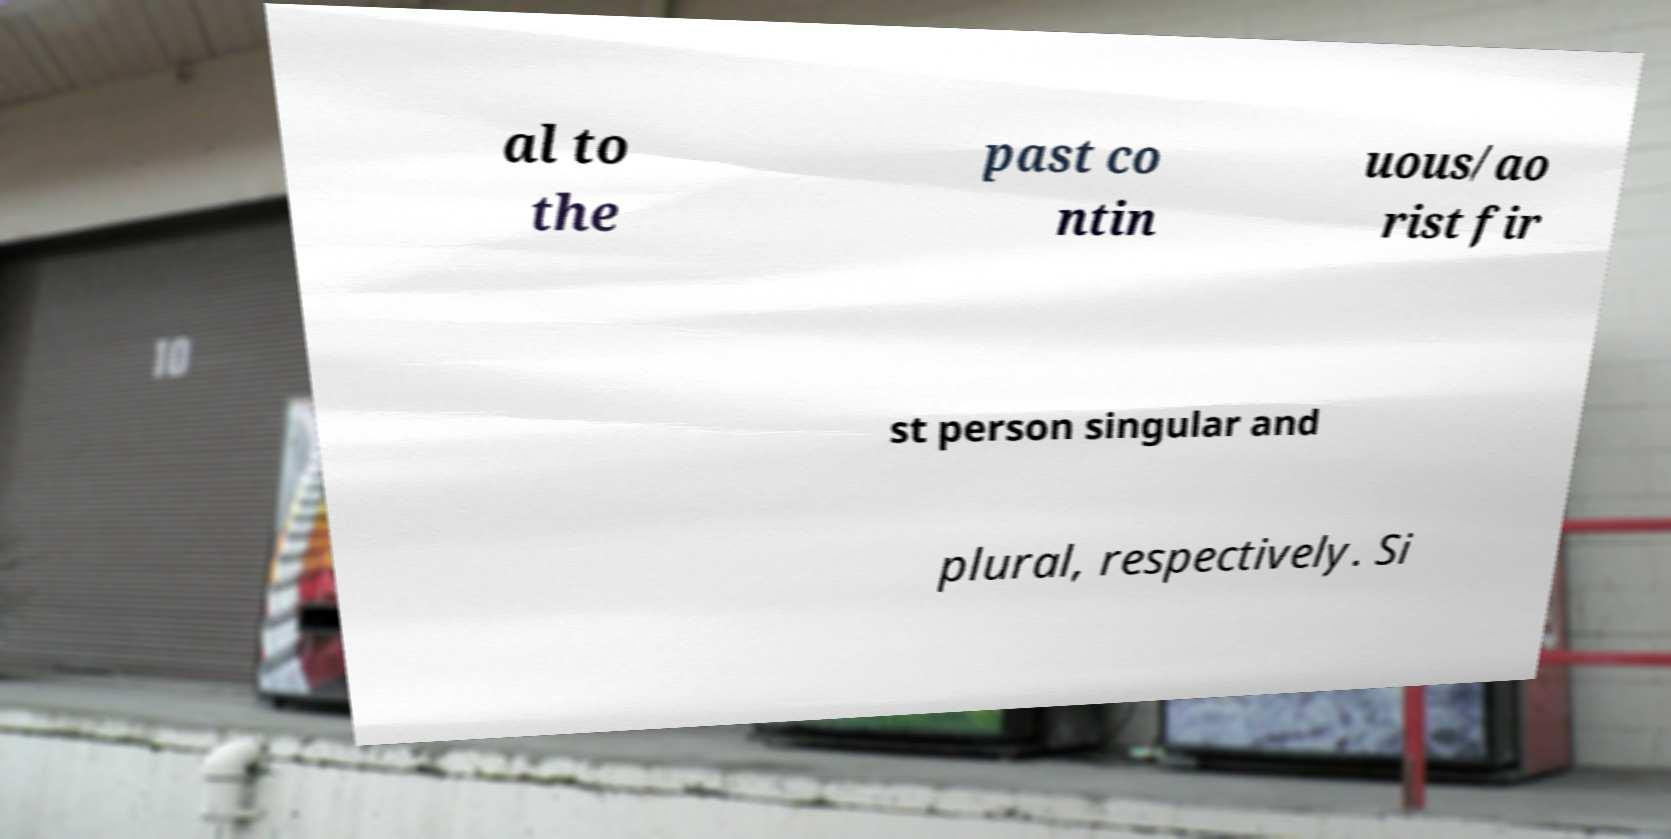Could you extract and type out the text from this image? al to the past co ntin uous/ao rist fir st person singular and plural, respectively. Si 